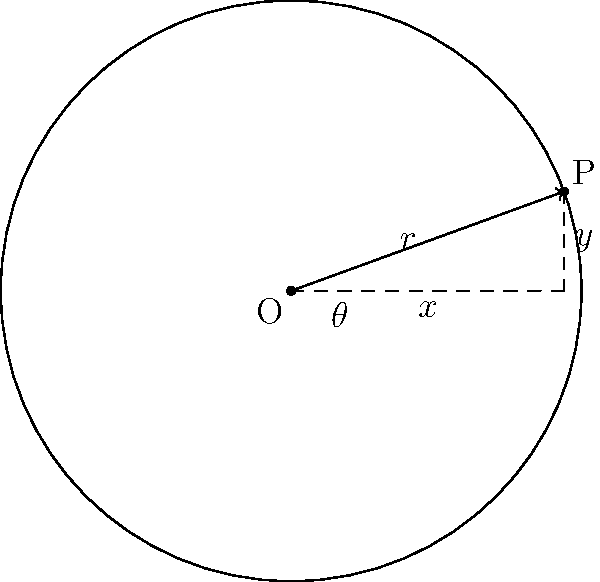In gear design, the pressure angle of a gear tooth profile is crucial for optimal performance. Consider a gear with a pitch circle radius of 60 mm. If the pressure angle is 20°, what is the height of the gear tooth at the pitch circle? Round your answer to the nearest 0.1 mm. To solve this problem, we'll use trigonometry to find the height of the gear tooth at the pitch circle. Let's break it down step-by-step:

1) In the diagram, the radius of the pitch circle is represented by $r$, and the pressure angle by $\theta$.

2) The height of the gear tooth at the pitch circle is represented by $y$ in the diagram.

3) We can use the sine function to find $y$:

   $\sin(\theta) = \frac{y}{r}$

4) Rearranging this equation:

   $y = r \cdot \sin(\theta)$

5) We're given:
   - Radius ($r$) = 60 mm
   - Pressure angle ($\theta$) = 20°

6) Let's substitute these values:

   $y = 60 \cdot \sin(20°)$

7) Using a calculator (or trigonometric tables):

   $y = 60 \cdot 0.3420201433$

8) This gives us:

   $y = 20.52120860$ mm

9) Rounding to the nearest 0.1 mm:

   $y \approx 20.5$ mm

Therefore, the height of the gear tooth at the pitch circle is approximately 20.5 mm.
Answer: 20.5 mm 